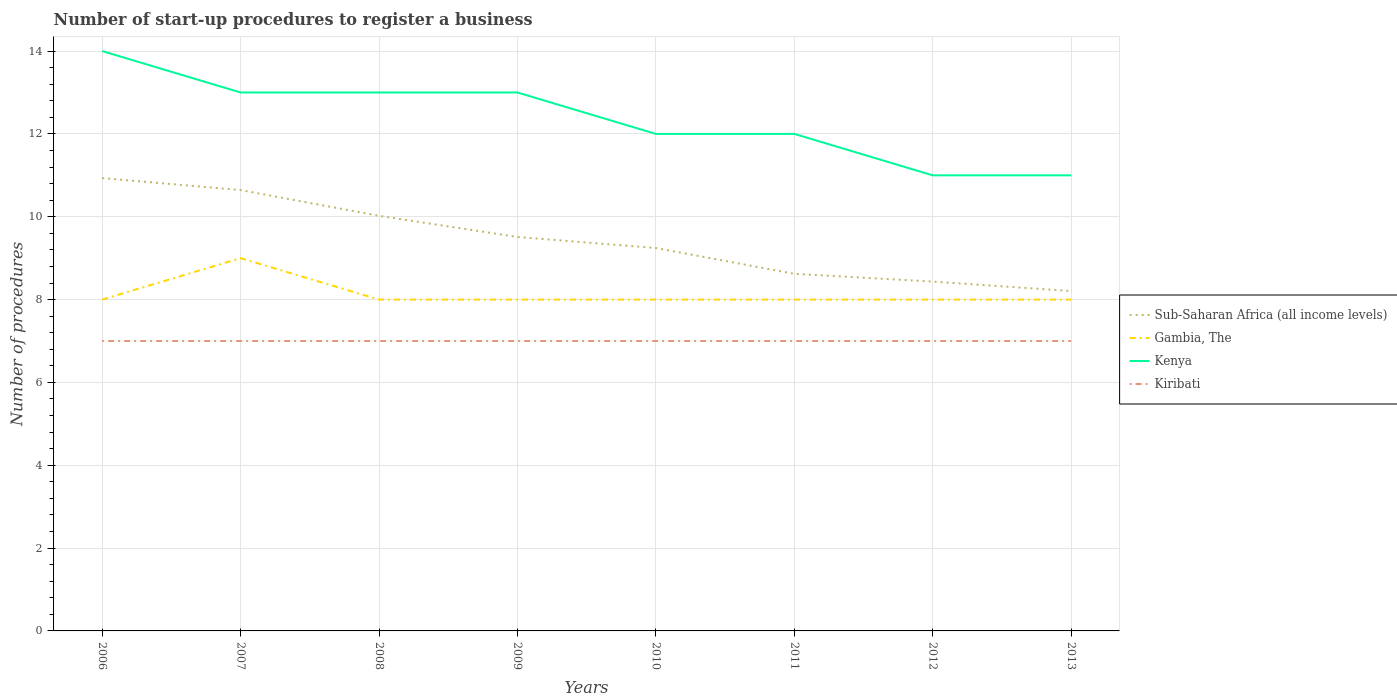Does the line corresponding to Sub-Saharan Africa (all income levels) intersect with the line corresponding to Kenya?
Give a very brief answer. No. Across all years, what is the maximum number of procedures required to register a business in Sub-Saharan Africa (all income levels)?
Offer a very short reply. 8.21. In which year was the number of procedures required to register a business in Kiribati maximum?
Your answer should be compact. 2006. What is the total number of procedures required to register a business in Kenya in the graph?
Your response must be concise. 1. What is the difference between the highest and the second highest number of procedures required to register a business in Gambia, The?
Ensure brevity in your answer.  1. Is the number of procedures required to register a business in Kiribati strictly greater than the number of procedures required to register a business in Gambia, The over the years?
Offer a terse response. Yes. How many years are there in the graph?
Make the answer very short. 8. Does the graph contain grids?
Your answer should be compact. Yes. Where does the legend appear in the graph?
Your response must be concise. Center right. How many legend labels are there?
Offer a terse response. 4. What is the title of the graph?
Keep it short and to the point. Number of start-up procedures to register a business. Does "Azerbaijan" appear as one of the legend labels in the graph?
Your answer should be very brief. No. What is the label or title of the X-axis?
Give a very brief answer. Years. What is the label or title of the Y-axis?
Keep it short and to the point. Number of procedures. What is the Number of procedures in Sub-Saharan Africa (all income levels) in 2006?
Keep it short and to the point. 10.93. What is the Number of procedures in Kiribati in 2006?
Offer a terse response. 7. What is the Number of procedures of Sub-Saharan Africa (all income levels) in 2007?
Provide a succinct answer. 10.64. What is the Number of procedures of Sub-Saharan Africa (all income levels) in 2008?
Ensure brevity in your answer.  10.02. What is the Number of procedures of Kiribati in 2008?
Give a very brief answer. 7. What is the Number of procedures of Sub-Saharan Africa (all income levels) in 2009?
Keep it short and to the point. 9.51. What is the Number of procedures in Gambia, The in 2009?
Your answer should be very brief. 8. What is the Number of procedures of Kenya in 2009?
Make the answer very short. 13. What is the Number of procedures of Kiribati in 2009?
Make the answer very short. 7. What is the Number of procedures in Sub-Saharan Africa (all income levels) in 2010?
Offer a very short reply. 9.24. What is the Number of procedures of Kenya in 2010?
Offer a terse response. 12. What is the Number of procedures of Sub-Saharan Africa (all income levels) in 2011?
Provide a succinct answer. 8.62. What is the Number of procedures in Kenya in 2011?
Your answer should be very brief. 12. What is the Number of procedures in Sub-Saharan Africa (all income levels) in 2012?
Offer a very short reply. 8.43. What is the Number of procedures in Gambia, The in 2012?
Offer a terse response. 8. What is the Number of procedures in Kiribati in 2012?
Make the answer very short. 7. What is the Number of procedures of Sub-Saharan Africa (all income levels) in 2013?
Ensure brevity in your answer.  8.21. Across all years, what is the maximum Number of procedures in Sub-Saharan Africa (all income levels)?
Your response must be concise. 10.93. Across all years, what is the maximum Number of procedures of Gambia, The?
Provide a succinct answer. 9. Across all years, what is the maximum Number of procedures of Kiribati?
Make the answer very short. 7. Across all years, what is the minimum Number of procedures in Sub-Saharan Africa (all income levels)?
Ensure brevity in your answer.  8.21. What is the total Number of procedures of Sub-Saharan Africa (all income levels) in the graph?
Make the answer very short. 75.62. What is the total Number of procedures of Kenya in the graph?
Offer a terse response. 99. What is the difference between the Number of procedures of Sub-Saharan Africa (all income levels) in 2006 and that in 2007?
Offer a terse response. 0.29. What is the difference between the Number of procedures in Kenya in 2006 and that in 2007?
Keep it short and to the point. 1. What is the difference between the Number of procedures of Kiribati in 2006 and that in 2007?
Provide a succinct answer. 0. What is the difference between the Number of procedures of Sub-Saharan Africa (all income levels) in 2006 and that in 2008?
Provide a succinct answer. 0.91. What is the difference between the Number of procedures of Gambia, The in 2006 and that in 2008?
Your answer should be very brief. 0. What is the difference between the Number of procedures in Sub-Saharan Africa (all income levels) in 2006 and that in 2009?
Provide a short and direct response. 1.42. What is the difference between the Number of procedures in Gambia, The in 2006 and that in 2009?
Provide a short and direct response. 0. What is the difference between the Number of procedures of Kiribati in 2006 and that in 2009?
Keep it short and to the point. 0. What is the difference between the Number of procedures of Sub-Saharan Africa (all income levels) in 2006 and that in 2010?
Your response must be concise. 1.69. What is the difference between the Number of procedures in Kenya in 2006 and that in 2010?
Your answer should be very brief. 2. What is the difference between the Number of procedures of Sub-Saharan Africa (all income levels) in 2006 and that in 2011?
Keep it short and to the point. 2.31. What is the difference between the Number of procedures in Kenya in 2006 and that in 2011?
Offer a terse response. 2. What is the difference between the Number of procedures of Sub-Saharan Africa (all income levels) in 2006 and that in 2012?
Offer a terse response. 2.5. What is the difference between the Number of procedures of Gambia, The in 2006 and that in 2012?
Make the answer very short. 0. What is the difference between the Number of procedures in Kiribati in 2006 and that in 2012?
Your answer should be compact. 0. What is the difference between the Number of procedures of Sub-Saharan Africa (all income levels) in 2006 and that in 2013?
Ensure brevity in your answer.  2.73. What is the difference between the Number of procedures of Sub-Saharan Africa (all income levels) in 2007 and that in 2008?
Your answer should be compact. 0.62. What is the difference between the Number of procedures in Kenya in 2007 and that in 2008?
Provide a short and direct response. 0. What is the difference between the Number of procedures of Sub-Saharan Africa (all income levels) in 2007 and that in 2009?
Offer a very short reply. 1.13. What is the difference between the Number of procedures in Gambia, The in 2007 and that in 2009?
Provide a succinct answer. 1. What is the difference between the Number of procedures of Kenya in 2007 and that in 2009?
Provide a succinct answer. 0. What is the difference between the Number of procedures of Kiribati in 2007 and that in 2009?
Ensure brevity in your answer.  0. What is the difference between the Number of procedures of Gambia, The in 2007 and that in 2010?
Ensure brevity in your answer.  1. What is the difference between the Number of procedures of Sub-Saharan Africa (all income levels) in 2007 and that in 2011?
Give a very brief answer. 2.02. What is the difference between the Number of procedures in Kenya in 2007 and that in 2011?
Keep it short and to the point. 1. What is the difference between the Number of procedures of Kiribati in 2007 and that in 2011?
Make the answer very short. 0. What is the difference between the Number of procedures of Sub-Saharan Africa (all income levels) in 2007 and that in 2012?
Give a very brief answer. 2.21. What is the difference between the Number of procedures in Gambia, The in 2007 and that in 2012?
Offer a terse response. 1. What is the difference between the Number of procedures in Kenya in 2007 and that in 2012?
Provide a succinct answer. 2. What is the difference between the Number of procedures of Sub-Saharan Africa (all income levels) in 2007 and that in 2013?
Your answer should be very brief. 2.44. What is the difference between the Number of procedures in Gambia, The in 2007 and that in 2013?
Provide a short and direct response. 1. What is the difference between the Number of procedures of Kenya in 2007 and that in 2013?
Your answer should be very brief. 2. What is the difference between the Number of procedures of Kiribati in 2007 and that in 2013?
Give a very brief answer. 0. What is the difference between the Number of procedures of Sub-Saharan Africa (all income levels) in 2008 and that in 2009?
Your response must be concise. 0.51. What is the difference between the Number of procedures in Kiribati in 2008 and that in 2009?
Your response must be concise. 0. What is the difference between the Number of procedures of Kenya in 2008 and that in 2010?
Make the answer very short. 1. What is the difference between the Number of procedures of Gambia, The in 2008 and that in 2011?
Your response must be concise. 0. What is the difference between the Number of procedures of Kiribati in 2008 and that in 2011?
Your response must be concise. 0. What is the difference between the Number of procedures in Sub-Saharan Africa (all income levels) in 2008 and that in 2012?
Give a very brief answer. 1.59. What is the difference between the Number of procedures in Kenya in 2008 and that in 2012?
Your response must be concise. 2. What is the difference between the Number of procedures of Kiribati in 2008 and that in 2012?
Keep it short and to the point. 0. What is the difference between the Number of procedures of Sub-Saharan Africa (all income levels) in 2008 and that in 2013?
Provide a succinct answer. 1.82. What is the difference between the Number of procedures in Sub-Saharan Africa (all income levels) in 2009 and that in 2010?
Keep it short and to the point. 0.27. What is the difference between the Number of procedures of Gambia, The in 2009 and that in 2010?
Give a very brief answer. 0. What is the difference between the Number of procedures in Kenya in 2009 and that in 2010?
Keep it short and to the point. 1. What is the difference between the Number of procedures in Sub-Saharan Africa (all income levels) in 2009 and that in 2011?
Keep it short and to the point. 0.89. What is the difference between the Number of procedures in Gambia, The in 2009 and that in 2011?
Provide a short and direct response. 0. What is the difference between the Number of procedures in Kenya in 2009 and that in 2011?
Provide a short and direct response. 1. What is the difference between the Number of procedures of Kiribati in 2009 and that in 2011?
Make the answer very short. 0. What is the difference between the Number of procedures in Sub-Saharan Africa (all income levels) in 2009 and that in 2012?
Make the answer very short. 1.08. What is the difference between the Number of procedures in Gambia, The in 2009 and that in 2012?
Make the answer very short. 0. What is the difference between the Number of procedures of Kenya in 2009 and that in 2012?
Make the answer very short. 2. What is the difference between the Number of procedures in Sub-Saharan Africa (all income levels) in 2009 and that in 2013?
Offer a terse response. 1.3. What is the difference between the Number of procedures in Gambia, The in 2009 and that in 2013?
Your response must be concise. 0. What is the difference between the Number of procedures in Kenya in 2009 and that in 2013?
Provide a succinct answer. 2. What is the difference between the Number of procedures of Kiribati in 2009 and that in 2013?
Offer a very short reply. 0. What is the difference between the Number of procedures in Sub-Saharan Africa (all income levels) in 2010 and that in 2011?
Provide a short and direct response. 0.62. What is the difference between the Number of procedures of Gambia, The in 2010 and that in 2011?
Provide a succinct answer. 0. What is the difference between the Number of procedures in Sub-Saharan Africa (all income levels) in 2010 and that in 2012?
Give a very brief answer. 0.81. What is the difference between the Number of procedures of Sub-Saharan Africa (all income levels) in 2010 and that in 2013?
Your response must be concise. 1.04. What is the difference between the Number of procedures of Gambia, The in 2010 and that in 2013?
Ensure brevity in your answer.  0. What is the difference between the Number of procedures in Kenya in 2010 and that in 2013?
Offer a very short reply. 1. What is the difference between the Number of procedures of Kiribati in 2010 and that in 2013?
Ensure brevity in your answer.  0. What is the difference between the Number of procedures of Sub-Saharan Africa (all income levels) in 2011 and that in 2012?
Provide a succinct answer. 0.19. What is the difference between the Number of procedures in Kenya in 2011 and that in 2012?
Make the answer very short. 1. What is the difference between the Number of procedures in Kiribati in 2011 and that in 2012?
Your response must be concise. 0. What is the difference between the Number of procedures in Sub-Saharan Africa (all income levels) in 2011 and that in 2013?
Offer a very short reply. 0.42. What is the difference between the Number of procedures of Gambia, The in 2011 and that in 2013?
Your answer should be very brief. 0. What is the difference between the Number of procedures of Kenya in 2011 and that in 2013?
Provide a short and direct response. 1. What is the difference between the Number of procedures of Sub-Saharan Africa (all income levels) in 2012 and that in 2013?
Your answer should be very brief. 0.23. What is the difference between the Number of procedures of Gambia, The in 2012 and that in 2013?
Your answer should be very brief. 0. What is the difference between the Number of procedures of Kiribati in 2012 and that in 2013?
Give a very brief answer. 0. What is the difference between the Number of procedures of Sub-Saharan Africa (all income levels) in 2006 and the Number of procedures of Gambia, The in 2007?
Offer a terse response. 1.93. What is the difference between the Number of procedures of Sub-Saharan Africa (all income levels) in 2006 and the Number of procedures of Kenya in 2007?
Ensure brevity in your answer.  -2.07. What is the difference between the Number of procedures of Sub-Saharan Africa (all income levels) in 2006 and the Number of procedures of Kiribati in 2007?
Your response must be concise. 3.93. What is the difference between the Number of procedures in Gambia, The in 2006 and the Number of procedures in Kenya in 2007?
Ensure brevity in your answer.  -5. What is the difference between the Number of procedures of Gambia, The in 2006 and the Number of procedures of Kiribati in 2007?
Make the answer very short. 1. What is the difference between the Number of procedures in Kenya in 2006 and the Number of procedures in Kiribati in 2007?
Your response must be concise. 7. What is the difference between the Number of procedures in Sub-Saharan Africa (all income levels) in 2006 and the Number of procedures in Gambia, The in 2008?
Offer a very short reply. 2.93. What is the difference between the Number of procedures of Sub-Saharan Africa (all income levels) in 2006 and the Number of procedures of Kenya in 2008?
Your answer should be compact. -2.07. What is the difference between the Number of procedures in Sub-Saharan Africa (all income levels) in 2006 and the Number of procedures in Kiribati in 2008?
Your answer should be very brief. 3.93. What is the difference between the Number of procedures in Kenya in 2006 and the Number of procedures in Kiribati in 2008?
Offer a very short reply. 7. What is the difference between the Number of procedures of Sub-Saharan Africa (all income levels) in 2006 and the Number of procedures of Gambia, The in 2009?
Keep it short and to the point. 2.93. What is the difference between the Number of procedures in Sub-Saharan Africa (all income levels) in 2006 and the Number of procedures in Kenya in 2009?
Provide a succinct answer. -2.07. What is the difference between the Number of procedures in Sub-Saharan Africa (all income levels) in 2006 and the Number of procedures in Kiribati in 2009?
Your response must be concise. 3.93. What is the difference between the Number of procedures in Kenya in 2006 and the Number of procedures in Kiribati in 2009?
Provide a succinct answer. 7. What is the difference between the Number of procedures in Sub-Saharan Africa (all income levels) in 2006 and the Number of procedures in Gambia, The in 2010?
Provide a short and direct response. 2.93. What is the difference between the Number of procedures of Sub-Saharan Africa (all income levels) in 2006 and the Number of procedures of Kenya in 2010?
Offer a very short reply. -1.07. What is the difference between the Number of procedures in Sub-Saharan Africa (all income levels) in 2006 and the Number of procedures in Kiribati in 2010?
Give a very brief answer. 3.93. What is the difference between the Number of procedures of Gambia, The in 2006 and the Number of procedures of Kiribati in 2010?
Offer a terse response. 1. What is the difference between the Number of procedures of Kenya in 2006 and the Number of procedures of Kiribati in 2010?
Offer a terse response. 7. What is the difference between the Number of procedures in Sub-Saharan Africa (all income levels) in 2006 and the Number of procedures in Gambia, The in 2011?
Provide a short and direct response. 2.93. What is the difference between the Number of procedures in Sub-Saharan Africa (all income levels) in 2006 and the Number of procedures in Kenya in 2011?
Provide a short and direct response. -1.07. What is the difference between the Number of procedures of Sub-Saharan Africa (all income levels) in 2006 and the Number of procedures of Kiribati in 2011?
Provide a short and direct response. 3.93. What is the difference between the Number of procedures of Gambia, The in 2006 and the Number of procedures of Kenya in 2011?
Provide a succinct answer. -4. What is the difference between the Number of procedures of Gambia, The in 2006 and the Number of procedures of Kiribati in 2011?
Keep it short and to the point. 1. What is the difference between the Number of procedures in Kenya in 2006 and the Number of procedures in Kiribati in 2011?
Provide a succinct answer. 7. What is the difference between the Number of procedures in Sub-Saharan Africa (all income levels) in 2006 and the Number of procedures in Gambia, The in 2012?
Your answer should be compact. 2.93. What is the difference between the Number of procedures in Sub-Saharan Africa (all income levels) in 2006 and the Number of procedures in Kenya in 2012?
Offer a terse response. -0.07. What is the difference between the Number of procedures of Sub-Saharan Africa (all income levels) in 2006 and the Number of procedures of Kiribati in 2012?
Make the answer very short. 3.93. What is the difference between the Number of procedures of Gambia, The in 2006 and the Number of procedures of Kiribati in 2012?
Your answer should be compact. 1. What is the difference between the Number of procedures of Kenya in 2006 and the Number of procedures of Kiribati in 2012?
Your answer should be very brief. 7. What is the difference between the Number of procedures of Sub-Saharan Africa (all income levels) in 2006 and the Number of procedures of Gambia, The in 2013?
Provide a succinct answer. 2.93. What is the difference between the Number of procedures in Sub-Saharan Africa (all income levels) in 2006 and the Number of procedures in Kenya in 2013?
Offer a very short reply. -0.07. What is the difference between the Number of procedures of Sub-Saharan Africa (all income levels) in 2006 and the Number of procedures of Kiribati in 2013?
Your response must be concise. 3.93. What is the difference between the Number of procedures in Gambia, The in 2006 and the Number of procedures in Kiribati in 2013?
Offer a terse response. 1. What is the difference between the Number of procedures in Kenya in 2006 and the Number of procedures in Kiribati in 2013?
Provide a succinct answer. 7. What is the difference between the Number of procedures of Sub-Saharan Africa (all income levels) in 2007 and the Number of procedures of Gambia, The in 2008?
Ensure brevity in your answer.  2.64. What is the difference between the Number of procedures of Sub-Saharan Africa (all income levels) in 2007 and the Number of procedures of Kenya in 2008?
Ensure brevity in your answer.  -2.36. What is the difference between the Number of procedures of Sub-Saharan Africa (all income levels) in 2007 and the Number of procedures of Kiribati in 2008?
Provide a short and direct response. 3.64. What is the difference between the Number of procedures in Gambia, The in 2007 and the Number of procedures in Kenya in 2008?
Offer a terse response. -4. What is the difference between the Number of procedures in Gambia, The in 2007 and the Number of procedures in Kiribati in 2008?
Ensure brevity in your answer.  2. What is the difference between the Number of procedures in Kenya in 2007 and the Number of procedures in Kiribati in 2008?
Make the answer very short. 6. What is the difference between the Number of procedures in Sub-Saharan Africa (all income levels) in 2007 and the Number of procedures in Gambia, The in 2009?
Offer a very short reply. 2.64. What is the difference between the Number of procedures in Sub-Saharan Africa (all income levels) in 2007 and the Number of procedures in Kenya in 2009?
Keep it short and to the point. -2.36. What is the difference between the Number of procedures in Sub-Saharan Africa (all income levels) in 2007 and the Number of procedures in Kiribati in 2009?
Your answer should be very brief. 3.64. What is the difference between the Number of procedures in Sub-Saharan Africa (all income levels) in 2007 and the Number of procedures in Gambia, The in 2010?
Keep it short and to the point. 2.64. What is the difference between the Number of procedures of Sub-Saharan Africa (all income levels) in 2007 and the Number of procedures of Kenya in 2010?
Provide a short and direct response. -1.36. What is the difference between the Number of procedures in Sub-Saharan Africa (all income levels) in 2007 and the Number of procedures in Kiribati in 2010?
Your answer should be compact. 3.64. What is the difference between the Number of procedures in Gambia, The in 2007 and the Number of procedures in Kenya in 2010?
Provide a succinct answer. -3. What is the difference between the Number of procedures in Kenya in 2007 and the Number of procedures in Kiribati in 2010?
Give a very brief answer. 6. What is the difference between the Number of procedures of Sub-Saharan Africa (all income levels) in 2007 and the Number of procedures of Gambia, The in 2011?
Give a very brief answer. 2.64. What is the difference between the Number of procedures in Sub-Saharan Africa (all income levels) in 2007 and the Number of procedures in Kenya in 2011?
Offer a very short reply. -1.36. What is the difference between the Number of procedures in Sub-Saharan Africa (all income levels) in 2007 and the Number of procedures in Kiribati in 2011?
Give a very brief answer. 3.64. What is the difference between the Number of procedures of Gambia, The in 2007 and the Number of procedures of Kenya in 2011?
Give a very brief answer. -3. What is the difference between the Number of procedures in Gambia, The in 2007 and the Number of procedures in Kiribati in 2011?
Offer a terse response. 2. What is the difference between the Number of procedures in Sub-Saharan Africa (all income levels) in 2007 and the Number of procedures in Gambia, The in 2012?
Offer a terse response. 2.64. What is the difference between the Number of procedures of Sub-Saharan Africa (all income levels) in 2007 and the Number of procedures of Kenya in 2012?
Give a very brief answer. -0.36. What is the difference between the Number of procedures of Sub-Saharan Africa (all income levels) in 2007 and the Number of procedures of Kiribati in 2012?
Provide a succinct answer. 3.64. What is the difference between the Number of procedures in Sub-Saharan Africa (all income levels) in 2007 and the Number of procedures in Gambia, The in 2013?
Give a very brief answer. 2.64. What is the difference between the Number of procedures in Sub-Saharan Africa (all income levels) in 2007 and the Number of procedures in Kenya in 2013?
Your response must be concise. -0.36. What is the difference between the Number of procedures in Sub-Saharan Africa (all income levels) in 2007 and the Number of procedures in Kiribati in 2013?
Give a very brief answer. 3.64. What is the difference between the Number of procedures in Gambia, The in 2007 and the Number of procedures in Kiribati in 2013?
Your answer should be very brief. 2. What is the difference between the Number of procedures in Sub-Saharan Africa (all income levels) in 2008 and the Number of procedures in Gambia, The in 2009?
Give a very brief answer. 2.02. What is the difference between the Number of procedures in Sub-Saharan Africa (all income levels) in 2008 and the Number of procedures in Kenya in 2009?
Ensure brevity in your answer.  -2.98. What is the difference between the Number of procedures in Sub-Saharan Africa (all income levels) in 2008 and the Number of procedures in Kiribati in 2009?
Give a very brief answer. 3.02. What is the difference between the Number of procedures in Gambia, The in 2008 and the Number of procedures in Kiribati in 2009?
Provide a short and direct response. 1. What is the difference between the Number of procedures in Sub-Saharan Africa (all income levels) in 2008 and the Number of procedures in Gambia, The in 2010?
Offer a terse response. 2.02. What is the difference between the Number of procedures of Sub-Saharan Africa (all income levels) in 2008 and the Number of procedures of Kenya in 2010?
Your answer should be compact. -1.98. What is the difference between the Number of procedures of Sub-Saharan Africa (all income levels) in 2008 and the Number of procedures of Kiribati in 2010?
Your answer should be compact. 3.02. What is the difference between the Number of procedures of Kenya in 2008 and the Number of procedures of Kiribati in 2010?
Provide a succinct answer. 6. What is the difference between the Number of procedures in Sub-Saharan Africa (all income levels) in 2008 and the Number of procedures in Gambia, The in 2011?
Provide a short and direct response. 2.02. What is the difference between the Number of procedures of Sub-Saharan Africa (all income levels) in 2008 and the Number of procedures of Kenya in 2011?
Provide a short and direct response. -1.98. What is the difference between the Number of procedures in Sub-Saharan Africa (all income levels) in 2008 and the Number of procedures in Kiribati in 2011?
Your answer should be very brief. 3.02. What is the difference between the Number of procedures in Gambia, The in 2008 and the Number of procedures in Kenya in 2011?
Give a very brief answer. -4. What is the difference between the Number of procedures of Kenya in 2008 and the Number of procedures of Kiribati in 2011?
Offer a terse response. 6. What is the difference between the Number of procedures in Sub-Saharan Africa (all income levels) in 2008 and the Number of procedures in Gambia, The in 2012?
Provide a succinct answer. 2.02. What is the difference between the Number of procedures in Sub-Saharan Africa (all income levels) in 2008 and the Number of procedures in Kenya in 2012?
Keep it short and to the point. -0.98. What is the difference between the Number of procedures of Sub-Saharan Africa (all income levels) in 2008 and the Number of procedures of Kiribati in 2012?
Your response must be concise. 3.02. What is the difference between the Number of procedures in Gambia, The in 2008 and the Number of procedures in Kenya in 2012?
Give a very brief answer. -3. What is the difference between the Number of procedures of Gambia, The in 2008 and the Number of procedures of Kiribati in 2012?
Your response must be concise. 1. What is the difference between the Number of procedures of Kenya in 2008 and the Number of procedures of Kiribati in 2012?
Keep it short and to the point. 6. What is the difference between the Number of procedures in Sub-Saharan Africa (all income levels) in 2008 and the Number of procedures in Gambia, The in 2013?
Give a very brief answer. 2.02. What is the difference between the Number of procedures of Sub-Saharan Africa (all income levels) in 2008 and the Number of procedures of Kenya in 2013?
Offer a very short reply. -0.98. What is the difference between the Number of procedures in Sub-Saharan Africa (all income levels) in 2008 and the Number of procedures in Kiribati in 2013?
Your answer should be very brief. 3.02. What is the difference between the Number of procedures of Sub-Saharan Africa (all income levels) in 2009 and the Number of procedures of Gambia, The in 2010?
Ensure brevity in your answer.  1.51. What is the difference between the Number of procedures in Sub-Saharan Africa (all income levels) in 2009 and the Number of procedures in Kenya in 2010?
Your response must be concise. -2.49. What is the difference between the Number of procedures in Sub-Saharan Africa (all income levels) in 2009 and the Number of procedures in Kiribati in 2010?
Make the answer very short. 2.51. What is the difference between the Number of procedures in Sub-Saharan Africa (all income levels) in 2009 and the Number of procedures in Gambia, The in 2011?
Provide a short and direct response. 1.51. What is the difference between the Number of procedures in Sub-Saharan Africa (all income levels) in 2009 and the Number of procedures in Kenya in 2011?
Offer a terse response. -2.49. What is the difference between the Number of procedures of Sub-Saharan Africa (all income levels) in 2009 and the Number of procedures of Kiribati in 2011?
Keep it short and to the point. 2.51. What is the difference between the Number of procedures of Gambia, The in 2009 and the Number of procedures of Kenya in 2011?
Provide a succinct answer. -4. What is the difference between the Number of procedures in Gambia, The in 2009 and the Number of procedures in Kiribati in 2011?
Offer a very short reply. 1. What is the difference between the Number of procedures in Kenya in 2009 and the Number of procedures in Kiribati in 2011?
Provide a succinct answer. 6. What is the difference between the Number of procedures in Sub-Saharan Africa (all income levels) in 2009 and the Number of procedures in Gambia, The in 2012?
Provide a short and direct response. 1.51. What is the difference between the Number of procedures in Sub-Saharan Africa (all income levels) in 2009 and the Number of procedures in Kenya in 2012?
Give a very brief answer. -1.49. What is the difference between the Number of procedures of Sub-Saharan Africa (all income levels) in 2009 and the Number of procedures of Kiribati in 2012?
Ensure brevity in your answer.  2.51. What is the difference between the Number of procedures in Gambia, The in 2009 and the Number of procedures in Kenya in 2012?
Keep it short and to the point. -3. What is the difference between the Number of procedures in Kenya in 2009 and the Number of procedures in Kiribati in 2012?
Keep it short and to the point. 6. What is the difference between the Number of procedures in Sub-Saharan Africa (all income levels) in 2009 and the Number of procedures in Gambia, The in 2013?
Your answer should be compact. 1.51. What is the difference between the Number of procedures of Sub-Saharan Africa (all income levels) in 2009 and the Number of procedures of Kenya in 2013?
Your answer should be very brief. -1.49. What is the difference between the Number of procedures in Sub-Saharan Africa (all income levels) in 2009 and the Number of procedures in Kiribati in 2013?
Offer a very short reply. 2.51. What is the difference between the Number of procedures in Sub-Saharan Africa (all income levels) in 2010 and the Number of procedures in Gambia, The in 2011?
Keep it short and to the point. 1.24. What is the difference between the Number of procedures of Sub-Saharan Africa (all income levels) in 2010 and the Number of procedures of Kenya in 2011?
Offer a very short reply. -2.76. What is the difference between the Number of procedures of Sub-Saharan Africa (all income levels) in 2010 and the Number of procedures of Kiribati in 2011?
Provide a succinct answer. 2.24. What is the difference between the Number of procedures in Gambia, The in 2010 and the Number of procedures in Kenya in 2011?
Make the answer very short. -4. What is the difference between the Number of procedures in Sub-Saharan Africa (all income levels) in 2010 and the Number of procedures in Gambia, The in 2012?
Provide a short and direct response. 1.24. What is the difference between the Number of procedures of Sub-Saharan Africa (all income levels) in 2010 and the Number of procedures of Kenya in 2012?
Provide a short and direct response. -1.76. What is the difference between the Number of procedures of Sub-Saharan Africa (all income levels) in 2010 and the Number of procedures of Kiribati in 2012?
Offer a very short reply. 2.24. What is the difference between the Number of procedures in Sub-Saharan Africa (all income levels) in 2010 and the Number of procedures in Gambia, The in 2013?
Make the answer very short. 1.24. What is the difference between the Number of procedures of Sub-Saharan Africa (all income levels) in 2010 and the Number of procedures of Kenya in 2013?
Give a very brief answer. -1.76. What is the difference between the Number of procedures in Sub-Saharan Africa (all income levels) in 2010 and the Number of procedures in Kiribati in 2013?
Your response must be concise. 2.24. What is the difference between the Number of procedures of Gambia, The in 2010 and the Number of procedures of Kenya in 2013?
Provide a succinct answer. -3. What is the difference between the Number of procedures in Gambia, The in 2010 and the Number of procedures in Kiribati in 2013?
Offer a terse response. 1. What is the difference between the Number of procedures in Sub-Saharan Africa (all income levels) in 2011 and the Number of procedures in Gambia, The in 2012?
Provide a short and direct response. 0.62. What is the difference between the Number of procedures in Sub-Saharan Africa (all income levels) in 2011 and the Number of procedures in Kenya in 2012?
Offer a terse response. -2.38. What is the difference between the Number of procedures in Sub-Saharan Africa (all income levels) in 2011 and the Number of procedures in Kiribati in 2012?
Offer a terse response. 1.62. What is the difference between the Number of procedures of Gambia, The in 2011 and the Number of procedures of Kenya in 2012?
Keep it short and to the point. -3. What is the difference between the Number of procedures in Gambia, The in 2011 and the Number of procedures in Kiribati in 2012?
Provide a succinct answer. 1. What is the difference between the Number of procedures of Sub-Saharan Africa (all income levels) in 2011 and the Number of procedures of Gambia, The in 2013?
Give a very brief answer. 0.62. What is the difference between the Number of procedures of Sub-Saharan Africa (all income levels) in 2011 and the Number of procedures of Kenya in 2013?
Your response must be concise. -2.38. What is the difference between the Number of procedures in Sub-Saharan Africa (all income levels) in 2011 and the Number of procedures in Kiribati in 2013?
Your answer should be very brief. 1.62. What is the difference between the Number of procedures of Gambia, The in 2011 and the Number of procedures of Kenya in 2013?
Offer a terse response. -3. What is the difference between the Number of procedures in Sub-Saharan Africa (all income levels) in 2012 and the Number of procedures in Gambia, The in 2013?
Ensure brevity in your answer.  0.43. What is the difference between the Number of procedures in Sub-Saharan Africa (all income levels) in 2012 and the Number of procedures in Kenya in 2013?
Keep it short and to the point. -2.57. What is the difference between the Number of procedures in Sub-Saharan Africa (all income levels) in 2012 and the Number of procedures in Kiribati in 2013?
Make the answer very short. 1.43. What is the difference between the Number of procedures in Gambia, The in 2012 and the Number of procedures in Kenya in 2013?
Keep it short and to the point. -3. What is the difference between the Number of procedures in Gambia, The in 2012 and the Number of procedures in Kiribati in 2013?
Offer a terse response. 1. What is the average Number of procedures in Sub-Saharan Africa (all income levels) per year?
Offer a very short reply. 9.45. What is the average Number of procedures in Gambia, The per year?
Ensure brevity in your answer.  8.12. What is the average Number of procedures in Kenya per year?
Provide a short and direct response. 12.38. What is the average Number of procedures of Kiribati per year?
Your response must be concise. 7. In the year 2006, what is the difference between the Number of procedures in Sub-Saharan Africa (all income levels) and Number of procedures in Gambia, The?
Give a very brief answer. 2.93. In the year 2006, what is the difference between the Number of procedures in Sub-Saharan Africa (all income levels) and Number of procedures in Kenya?
Keep it short and to the point. -3.07. In the year 2006, what is the difference between the Number of procedures in Sub-Saharan Africa (all income levels) and Number of procedures in Kiribati?
Provide a short and direct response. 3.93. In the year 2006, what is the difference between the Number of procedures in Gambia, The and Number of procedures in Kiribati?
Keep it short and to the point. 1. In the year 2007, what is the difference between the Number of procedures of Sub-Saharan Africa (all income levels) and Number of procedures of Gambia, The?
Give a very brief answer. 1.64. In the year 2007, what is the difference between the Number of procedures of Sub-Saharan Africa (all income levels) and Number of procedures of Kenya?
Your response must be concise. -2.36. In the year 2007, what is the difference between the Number of procedures in Sub-Saharan Africa (all income levels) and Number of procedures in Kiribati?
Your answer should be compact. 3.64. In the year 2007, what is the difference between the Number of procedures in Gambia, The and Number of procedures in Kenya?
Your answer should be very brief. -4. In the year 2007, what is the difference between the Number of procedures in Kenya and Number of procedures in Kiribati?
Provide a succinct answer. 6. In the year 2008, what is the difference between the Number of procedures of Sub-Saharan Africa (all income levels) and Number of procedures of Gambia, The?
Offer a very short reply. 2.02. In the year 2008, what is the difference between the Number of procedures of Sub-Saharan Africa (all income levels) and Number of procedures of Kenya?
Make the answer very short. -2.98. In the year 2008, what is the difference between the Number of procedures of Sub-Saharan Africa (all income levels) and Number of procedures of Kiribati?
Provide a succinct answer. 3.02. In the year 2009, what is the difference between the Number of procedures of Sub-Saharan Africa (all income levels) and Number of procedures of Gambia, The?
Your answer should be very brief. 1.51. In the year 2009, what is the difference between the Number of procedures in Sub-Saharan Africa (all income levels) and Number of procedures in Kenya?
Make the answer very short. -3.49. In the year 2009, what is the difference between the Number of procedures of Sub-Saharan Africa (all income levels) and Number of procedures of Kiribati?
Provide a short and direct response. 2.51. In the year 2009, what is the difference between the Number of procedures in Gambia, The and Number of procedures in Kenya?
Your response must be concise. -5. In the year 2009, what is the difference between the Number of procedures in Gambia, The and Number of procedures in Kiribati?
Offer a terse response. 1. In the year 2009, what is the difference between the Number of procedures in Kenya and Number of procedures in Kiribati?
Provide a succinct answer. 6. In the year 2010, what is the difference between the Number of procedures in Sub-Saharan Africa (all income levels) and Number of procedures in Gambia, The?
Ensure brevity in your answer.  1.24. In the year 2010, what is the difference between the Number of procedures in Sub-Saharan Africa (all income levels) and Number of procedures in Kenya?
Offer a very short reply. -2.76. In the year 2010, what is the difference between the Number of procedures of Sub-Saharan Africa (all income levels) and Number of procedures of Kiribati?
Ensure brevity in your answer.  2.24. In the year 2011, what is the difference between the Number of procedures in Sub-Saharan Africa (all income levels) and Number of procedures in Gambia, The?
Your answer should be compact. 0.62. In the year 2011, what is the difference between the Number of procedures of Sub-Saharan Africa (all income levels) and Number of procedures of Kenya?
Offer a terse response. -3.38. In the year 2011, what is the difference between the Number of procedures of Sub-Saharan Africa (all income levels) and Number of procedures of Kiribati?
Your answer should be very brief. 1.62. In the year 2011, what is the difference between the Number of procedures of Gambia, The and Number of procedures of Kenya?
Make the answer very short. -4. In the year 2012, what is the difference between the Number of procedures of Sub-Saharan Africa (all income levels) and Number of procedures of Gambia, The?
Keep it short and to the point. 0.43. In the year 2012, what is the difference between the Number of procedures of Sub-Saharan Africa (all income levels) and Number of procedures of Kenya?
Make the answer very short. -2.57. In the year 2012, what is the difference between the Number of procedures of Sub-Saharan Africa (all income levels) and Number of procedures of Kiribati?
Your answer should be very brief. 1.43. In the year 2012, what is the difference between the Number of procedures in Gambia, The and Number of procedures in Kenya?
Make the answer very short. -3. In the year 2012, what is the difference between the Number of procedures in Gambia, The and Number of procedures in Kiribati?
Offer a terse response. 1. In the year 2013, what is the difference between the Number of procedures in Sub-Saharan Africa (all income levels) and Number of procedures in Gambia, The?
Provide a succinct answer. 0.21. In the year 2013, what is the difference between the Number of procedures of Sub-Saharan Africa (all income levels) and Number of procedures of Kenya?
Give a very brief answer. -2.79. In the year 2013, what is the difference between the Number of procedures in Sub-Saharan Africa (all income levels) and Number of procedures in Kiribati?
Keep it short and to the point. 1.21. In the year 2013, what is the difference between the Number of procedures of Gambia, The and Number of procedures of Kiribati?
Offer a very short reply. 1. What is the ratio of the Number of procedures in Sub-Saharan Africa (all income levels) in 2006 to that in 2007?
Provide a succinct answer. 1.03. What is the ratio of the Number of procedures in Gambia, The in 2006 to that in 2007?
Provide a short and direct response. 0.89. What is the ratio of the Number of procedures of Kenya in 2006 to that in 2007?
Give a very brief answer. 1.08. What is the ratio of the Number of procedures of Sub-Saharan Africa (all income levels) in 2006 to that in 2008?
Keep it short and to the point. 1.09. What is the ratio of the Number of procedures of Gambia, The in 2006 to that in 2008?
Make the answer very short. 1. What is the ratio of the Number of procedures of Kenya in 2006 to that in 2008?
Keep it short and to the point. 1.08. What is the ratio of the Number of procedures in Sub-Saharan Africa (all income levels) in 2006 to that in 2009?
Your answer should be compact. 1.15. What is the ratio of the Number of procedures of Gambia, The in 2006 to that in 2009?
Offer a very short reply. 1. What is the ratio of the Number of procedures in Sub-Saharan Africa (all income levels) in 2006 to that in 2010?
Keep it short and to the point. 1.18. What is the ratio of the Number of procedures of Kiribati in 2006 to that in 2010?
Provide a succinct answer. 1. What is the ratio of the Number of procedures in Sub-Saharan Africa (all income levels) in 2006 to that in 2011?
Provide a succinct answer. 1.27. What is the ratio of the Number of procedures of Kenya in 2006 to that in 2011?
Provide a succinct answer. 1.17. What is the ratio of the Number of procedures in Sub-Saharan Africa (all income levels) in 2006 to that in 2012?
Offer a terse response. 1.3. What is the ratio of the Number of procedures in Kenya in 2006 to that in 2012?
Keep it short and to the point. 1.27. What is the ratio of the Number of procedures in Kiribati in 2006 to that in 2012?
Your answer should be compact. 1. What is the ratio of the Number of procedures in Sub-Saharan Africa (all income levels) in 2006 to that in 2013?
Provide a succinct answer. 1.33. What is the ratio of the Number of procedures of Kenya in 2006 to that in 2013?
Your response must be concise. 1.27. What is the ratio of the Number of procedures of Kiribati in 2006 to that in 2013?
Your answer should be compact. 1. What is the ratio of the Number of procedures of Sub-Saharan Africa (all income levels) in 2007 to that in 2008?
Provide a short and direct response. 1.06. What is the ratio of the Number of procedures of Gambia, The in 2007 to that in 2008?
Your answer should be very brief. 1.12. What is the ratio of the Number of procedures in Kenya in 2007 to that in 2008?
Your response must be concise. 1. What is the ratio of the Number of procedures in Kiribati in 2007 to that in 2008?
Offer a terse response. 1. What is the ratio of the Number of procedures of Sub-Saharan Africa (all income levels) in 2007 to that in 2009?
Offer a terse response. 1.12. What is the ratio of the Number of procedures in Gambia, The in 2007 to that in 2009?
Ensure brevity in your answer.  1.12. What is the ratio of the Number of procedures of Kenya in 2007 to that in 2009?
Give a very brief answer. 1. What is the ratio of the Number of procedures of Kiribati in 2007 to that in 2009?
Your answer should be very brief. 1. What is the ratio of the Number of procedures in Sub-Saharan Africa (all income levels) in 2007 to that in 2010?
Your answer should be very brief. 1.15. What is the ratio of the Number of procedures in Gambia, The in 2007 to that in 2010?
Give a very brief answer. 1.12. What is the ratio of the Number of procedures in Kiribati in 2007 to that in 2010?
Keep it short and to the point. 1. What is the ratio of the Number of procedures in Sub-Saharan Africa (all income levels) in 2007 to that in 2011?
Your answer should be very brief. 1.23. What is the ratio of the Number of procedures of Gambia, The in 2007 to that in 2011?
Your response must be concise. 1.12. What is the ratio of the Number of procedures of Sub-Saharan Africa (all income levels) in 2007 to that in 2012?
Provide a succinct answer. 1.26. What is the ratio of the Number of procedures of Kenya in 2007 to that in 2012?
Make the answer very short. 1.18. What is the ratio of the Number of procedures of Kiribati in 2007 to that in 2012?
Ensure brevity in your answer.  1. What is the ratio of the Number of procedures in Sub-Saharan Africa (all income levels) in 2007 to that in 2013?
Provide a succinct answer. 1.3. What is the ratio of the Number of procedures of Gambia, The in 2007 to that in 2013?
Offer a terse response. 1.12. What is the ratio of the Number of procedures of Kenya in 2007 to that in 2013?
Your answer should be very brief. 1.18. What is the ratio of the Number of procedures in Sub-Saharan Africa (all income levels) in 2008 to that in 2009?
Your answer should be very brief. 1.05. What is the ratio of the Number of procedures in Kenya in 2008 to that in 2009?
Offer a very short reply. 1. What is the ratio of the Number of procedures in Kiribati in 2008 to that in 2009?
Keep it short and to the point. 1. What is the ratio of the Number of procedures in Sub-Saharan Africa (all income levels) in 2008 to that in 2010?
Ensure brevity in your answer.  1.08. What is the ratio of the Number of procedures of Sub-Saharan Africa (all income levels) in 2008 to that in 2011?
Provide a succinct answer. 1.16. What is the ratio of the Number of procedures of Kenya in 2008 to that in 2011?
Offer a very short reply. 1.08. What is the ratio of the Number of procedures of Kiribati in 2008 to that in 2011?
Provide a short and direct response. 1. What is the ratio of the Number of procedures of Sub-Saharan Africa (all income levels) in 2008 to that in 2012?
Your answer should be very brief. 1.19. What is the ratio of the Number of procedures of Kenya in 2008 to that in 2012?
Ensure brevity in your answer.  1.18. What is the ratio of the Number of procedures in Kiribati in 2008 to that in 2012?
Keep it short and to the point. 1. What is the ratio of the Number of procedures in Sub-Saharan Africa (all income levels) in 2008 to that in 2013?
Provide a succinct answer. 1.22. What is the ratio of the Number of procedures of Gambia, The in 2008 to that in 2013?
Provide a succinct answer. 1. What is the ratio of the Number of procedures of Kenya in 2008 to that in 2013?
Your answer should be compact. 1.18. What is the ratio of the Number of procedures of Sub-Saharan Africa (all income levels) in 2009 to that in 2010?
Your answer should be very brief. 1.03. What is the ratio of the Number of procedures in Sub-Saharan Africa (all income levels) in 2009 to that in 2011?
Provide a succinct answer. 1.1. What is the ratio of the Number of procedures of Kenya in 2009 to that in 2011?
Your answer should be compact. 1.08. What is the ratio of the Number of procedures of Sub-Saharan Africa (all income levels) in 2009 to that in 2012?
Ensure brevity in your answer.  1.13. What is the ratio of the Number of procedures of Kenya in 2009 to that in 2012?
Your response must be concise. 1.18. What is the ratio of the Number of procedures of Kiribati in 2009 to that in 2012?
Your answer should be compact. 1. What is the ratio of the Number of procedures of Sub-Saharan Africa (all income levels) in 2009 to that in 2013?
Offer a very short reply. 1.16. What is the ratio of the Number of procedures of Kenya in 2009 to that in 2013?
Provide a short and direct response. 1.18. What is the ratio of the Number of procedures in Sub-Saharan Africa (all income levels) in 2010 to that in 2011?
Provide a succinct answer. 1.07. What is the ratio of the Number of procedures in Gambia, The in 2010 to that in 2011?
Provide a short and direct response. 1. What is the ratio of the Number of procedures in Kenya in 2010 to that in 2011?
Offer a very short reply. 1. What is the ratio of the Number of procedures of Kiribati in 2010 to that in 2011?
Make the answer very short. 1. What is the ratio of the Number of procedures of Sub-Saharan Africa (all income levels) in 2010 to that in 2012?
Provide a short and direct response. 1.1. What is the ratio of the Number of procedures of Kiribati in 2010 to that in 2012?
Give a very brief answer. 1. What is the ratio of the Number of procedures of Sub-Saharan Africa (all income levels) in 2010 to that in 2013?
Keep it short and to the point. 1.13. What is the ratio of the Number of procedures of Kenya in 2010 to that in 2013?
Your answer should be compact. 1.09. What is the ratio of the Number of procedures of Sub-Saharan Africa (all income levels) in 2011 to that in 2012?
Keep it short and to the point. 1.02. What is the ratio of the Number of procedures of Gambia, The in 2011 to that in 2012?
Provide a short and direct response. 1. What is the ratio of the Number of procedures of Sub-Saharan Africa (all income levels) in 2011 to that in 2013?
Keep it short and to the point. 1.05. What is the ratio of the Number of procedures of Sub-Saharan Africa (all income levels) in 2012 to that in 2013?
Provide a succinct answer. 1.03. What is the difference between the highest and the second highest Number of procedures of Sub-Saharan Africa (all income levels)?
Give a very brief answer. 0.29. What is the difference between the highest and the second highest Number of procedures in Kiribati?
Make the answer very short. 0. What is the difference between the highest and the lowest Number of procedures of Sub-Saharan Africa (all income levels)?
Make the answer very short. 2.73. What is the difference between the highest and the lowest Number of procedures of Kenya?
Give a very brief answer. 3. What is the difference between the highest and the lowest Number of procedures of Kiribati?
Your answer should be very brief. 0. 